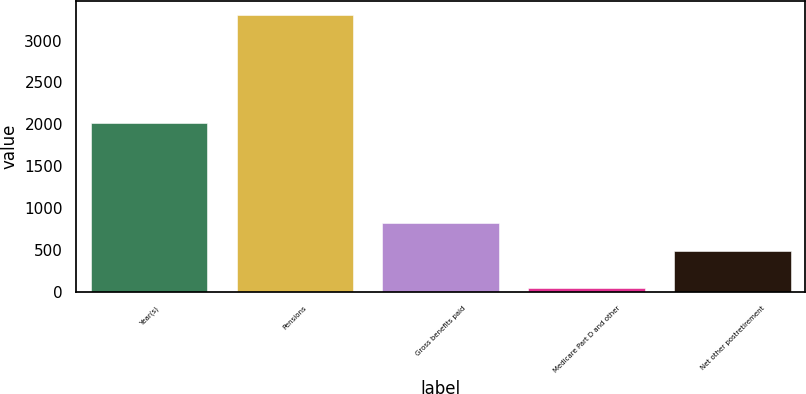Convert chart to OTSL. <chart><loc_0><loc_0><loc_500><loc_500><bar_chart><fcel>Year(s)<fcel>Pensions<fcel>Gross benefits paid<fcel>Medicare Part D and other<fcel>Net other postretirement<nl><fcel>2015<fcel>3309<fcel>820<fcel>49<fcel>494<nl></chart> 